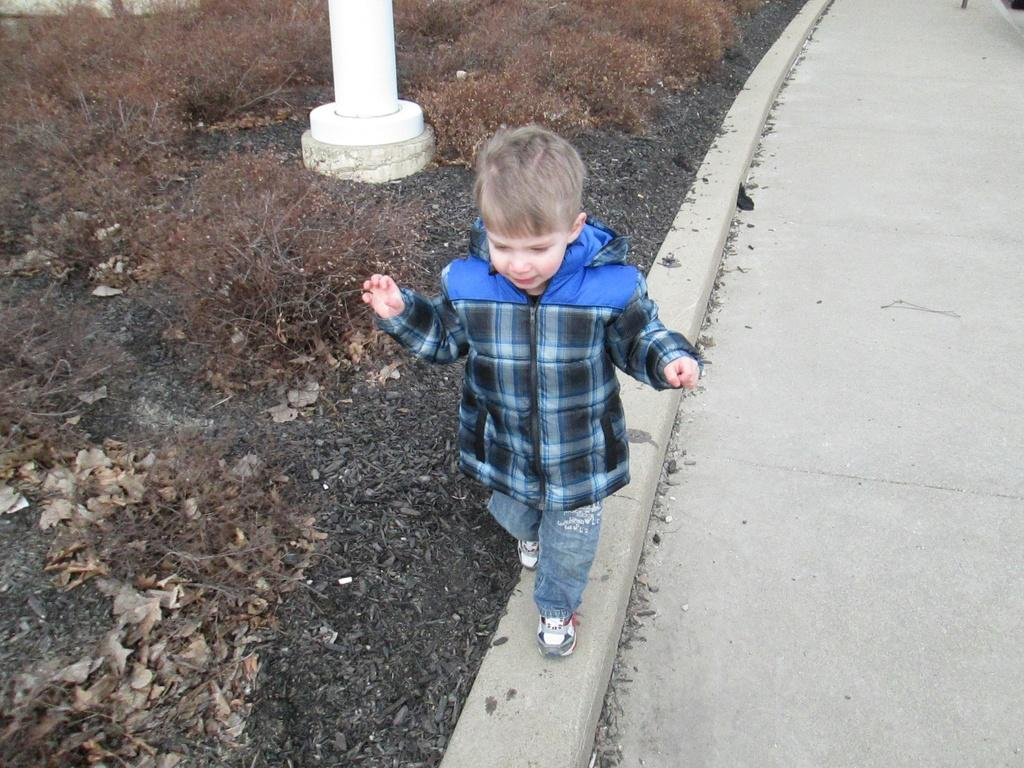Who is present in the image? There is a boy in the image. Where is the boy located in the image? The boy is standing beside a road. What is the boy wearing on his feet? The boy is wearing shoes. What can be seen in the background of the image? There is a white color pole and grass visible in the background of the image. What is the purpose of the dust in the image? There is no dust present in the image, so it cannot serve any purpose. 